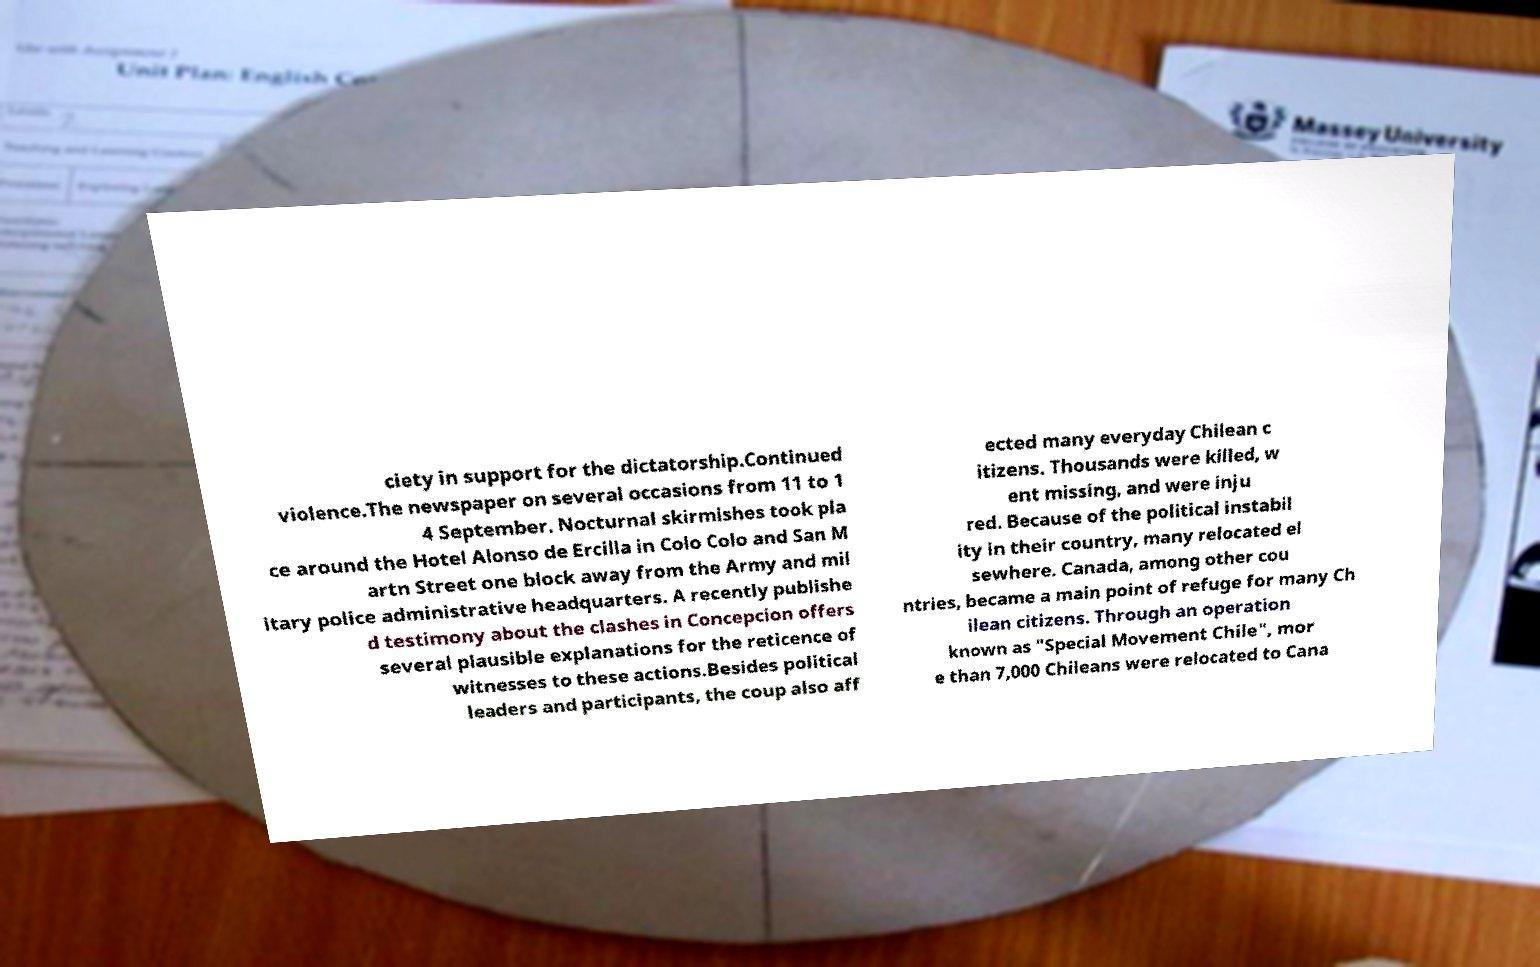There's text embedded in this image that I need extracted. Can you transcribe it verbatim? ciety in support for the dictatorship.Continued violence.The newspaper on several occasions from 11 to 1 4 September. Nocturnal skirmishes took pla ce around the Hotel Alonso de Ercilla in Colo Colo and San M artn Street one block away from the Army and mil itary police administrative headquarters. A recently publishe d testimony about the clashes in Concepcion offers several plausible explanations for the reticence of witnesses to these actions.Besides political leaders and participants, the coup also aff ected many everyday Chilean c itizens. Thousands were killed, w ent missing, and were inju red. Because of the political instabil ity in their country, many relocated el sewhere. Canada, among other cou ntries, became a main point of refuge for many Ch ilean citizens. Through an operation known as "Special Movement Chile", mor e than 7,000 Chileans were relocated to Cana 